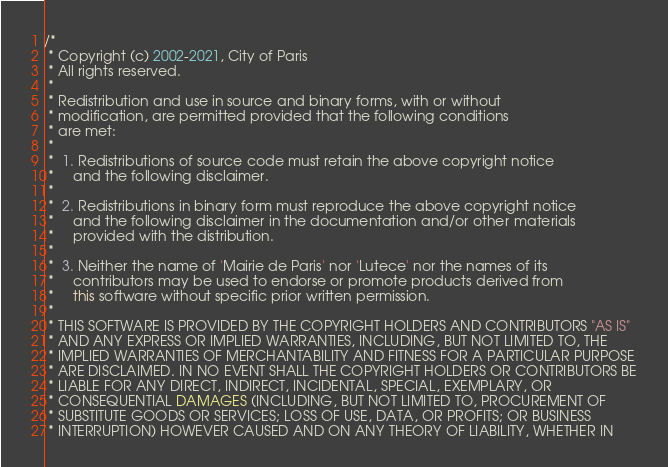Convert code to text. <code><loc_0><loc_0><loc_500><loc_500><_Java_>/*
 * Copyright (c) 2002-2021, City of Paris
 * All rights reserved.
 *
 * Redistribution and use in source and binary forms, with or without
 * modification, are permitted provided that the following conditions
 * are met:
 *
 *  1. Redistributions of source code must retain the above copyright notice
 *     and the following disclaimer.
 *
 *  2. Redistributions in binary form must reproduce the above copyright notice
 *     and the following disclaimer in the documentation and/or other materials
 *     provided with the distribution.
 *
 *  3. Neither the name of 'Mairie de Paris' nor 'Lutece' nor the names of its
 *     contributors may be used to endorse or promote products derived from
 *     this software without specific prior written permission.
 *
 * THIS SOFTWARE IS PROVIDED BY THE COPYRIGHT HOLDERS AND CONTRIBUTORS "AS IS"
 * AND ANY EXPRESS OR IMPLIED WARRANTIES, INCLUDING, BUT NOT LIMITED TO, THE
 * IMPLIED WARRANTIES OF MERCHANTABILITY AND FITNESS FOR A PARTICULAR PURPOSE
 * ARE DISCLAIMED. IN NO EVENT SHALL THE COPYRIGHT HOLDERS OR CONTRIBUTORS BE
 * LIABLE FOR ANY DIRECT, INDIRECT, INCIDENTAL, SPECIAL, EXEMPLARY, OR
 * CONSEQUENTIAL DAMAGES (INCLUDING, BUT NOT LIMITED TO, PROCUREMENT OF
 * SUBSTITUTE GOODS OR SERVICES; LOSS OF USE, DATA, OR PROFITS; OR BUSINESS
 * INTERRUPTION) HOWEVER CAUSED AND ON ANY THEORY OF LIABILITY, WHETHER IN</code> 